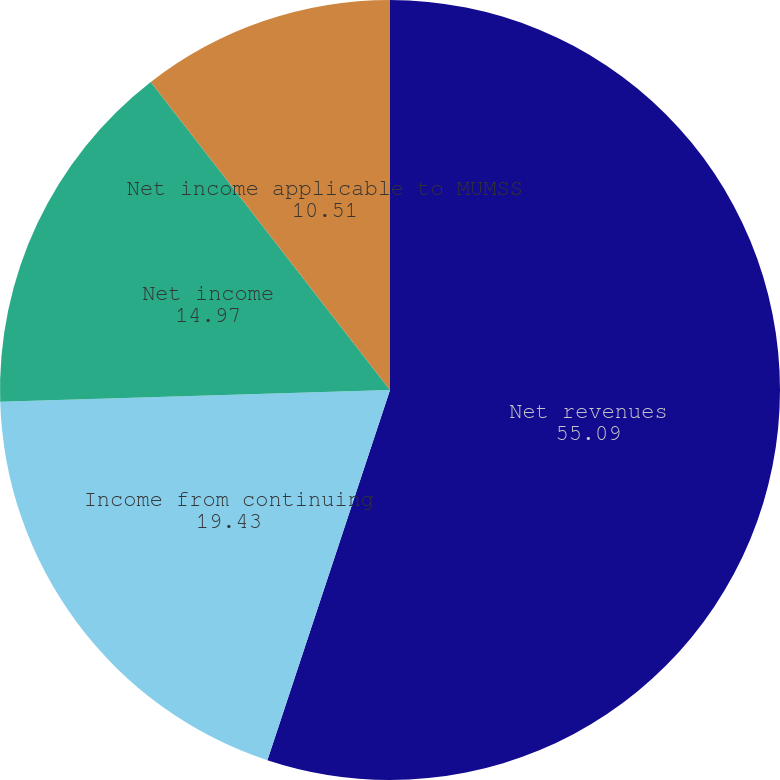Convert chart. <chart><loc_0><loc_0><loc_500><loc_500><pie_chart><fcel>Net revenues<fcel>Income from continuing<fcel>Net income<fcel>Net income applicable to MUMSS<nl><fcel>55.09%<fcel>19.43%<fcel>14.97%<fcel>10.51%<nl></chart> 